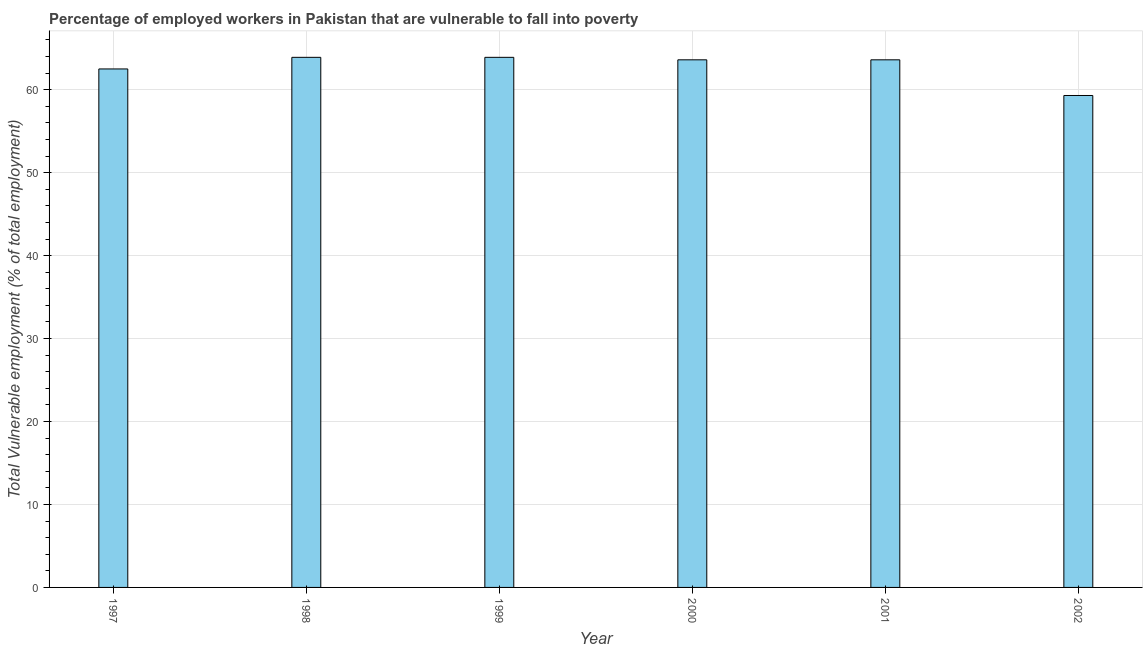Does the graph contain any zero values?
Offer a terse response. No. What is the title of the graph?
Your response must be concise. Percentage of employed workers in Pakistan that are vulnerable to fall into poverty. What is the label or title of the X-axis?
Offer a terse response. Year. What is the label or title of the Y-axis?
Provide a succinct answer. Total Vulnerable employment (% of total employment). What is the total vulnerable employment in 2000?
Make the answer very short. 63.6. Across all years, what is the maximum total vulnerable employment?
Make the answer very short. 63.9. Across all years, what is the minimum total vulnerable employment?
Make the answer very short. 59.3. In which year was the total vulnerable employment maximum?
Ensure brevity in your answer.  1998. What is the sum of the total vulnerable employment?
Give a very brief answer. 376.8. What is the average total vulnerable employment per year?
Keep it short and to the point. 62.8. What is the median total vulnerable employment?
Your answer should be very brief. 63.6. What is the ratio of the total vulnerable employment in 2001 to that in 2002?
Keep it short and to the point. 1.07. Is the total vulnerable employment in 1997 less than that in 2000?
Provide a short and direct response. Yes. Is the difference between the total vulnerable employment in 1997 and 2000 greater than the difference between any two years?
Your response must be concise. No. What is the difference between the highest and the second highest total vulnerable employment?
Your answer should be compact. 0. In how many years, is the total vulnerable employment greater than the average total vulnerable employment taken over all years?
Your answer should be compact. 4. Are all the bars in the graph horizontal?
Keep it short and to the point. No. What is the Total Vulnerable employment (% of total employment) of 1997?
Provide a succinct answer. 62.5. What is the Total Vulnerable employment (% of total employment) of 1998?
Your answer should be compact. 63.9. What is the Total Vulnerable employment (% of total employment) in 1999?
Offer a terse response. 63.9. What is the Total Vulnerable employment (% of total employment) in 2000?
Your answer should be compact. 63.6. What is the Total Vulnerable employment (% of total employment) in 2001?
Keep it short and to the point. 63.6. What is the Total Vulnerable employment (% of total employment) of 2002?
Offer a terse response. 59.3. What is the difference between the Total Vulnerable employment (% of total employment) in 1998 and 2000?
Your answer should be very brief. 0.3. What is the difference between the Total Vulnerable employment (% of total employment) in 1998 and 2001?
Give a very brief answer. 0.3. What is the difference between the Total Vulnerable employment (% of total employment) in 1998 and 2002?
Provide a succinct answer. 4.6. What is the difference between the Total Vulnerable employment (% of total employment) in 1999 and 2000?
Offer a terse response. 0.3. What is the difference between the Total Vulnerable employment (% of total employment) in 2000 and 2002?
Your response must be concise. 4.3. What is the difference between the Total Vulnerable employment (% of total employment) in 2001 and 2002?
Offer a very short reply. 4.3. What is the ratio of the Total Vulnerable employment (% of total employment) in 1997 to that in 1999?
Your response must be concise. 0.98. What is the ratio of the Total Vulnerable employment (% of total employment) in 1997 to that in 2001?
Keep it short and to the point. 0.98. What is the ratio of the Total Vulnerable employment (% of total employment) in 1997 to that in 2002?
Ensure brevity in your answer.  1.05. What is the ratio of the Total Vulnerable employment (% of total employment) in 1998 to that in 2000?
Ensure brevity in your answer.  1. What is the ratio of the Total Vulnerable employment (% of total employment) in 1998 to that in 2001?
Your answer should be very brief. 1. What is the ratio of the Total Vulnerable employment (% of total employment) in 1998 to that in 2002?
Offer a very short reply. 1.08. What is the ratio of the Total Vulnerable employment (% of total employment) in 1999 to that in 2002?
Ensure brevity in your answer.  1.08. What is the ratio of the Total Vulnerable employment (% of total employment) in 2000 to that in 2002?
Make the answer very short. 1.07. What is the ratio of the Total Vulnerable employment (% of total employment) in 2001 to that in 2002?
Give a very brief answer. 1.07. 